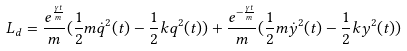Convert formula to latex. <formula><loc_0><loc_0><loc_500><loc_500>L _ { d } = \frac { e ^ { { \frac { \gamma t } { m } } } } { m } ( \frac { 1 } { 2 } m \dot { q } ^ { 2 } ( t ) - \frac { 1 } { 2 } k q ^ { 2 } ( t ) ) + \frac { e ^ { { - \frac { \gamma t } { m } } } } { m } ( \frac { 1 } { 2 } m \dot { y } ^ { 2 } ( t ) - \frac { 1 } { 2 } k y ^ { 2 } ( t ) )</formula> 